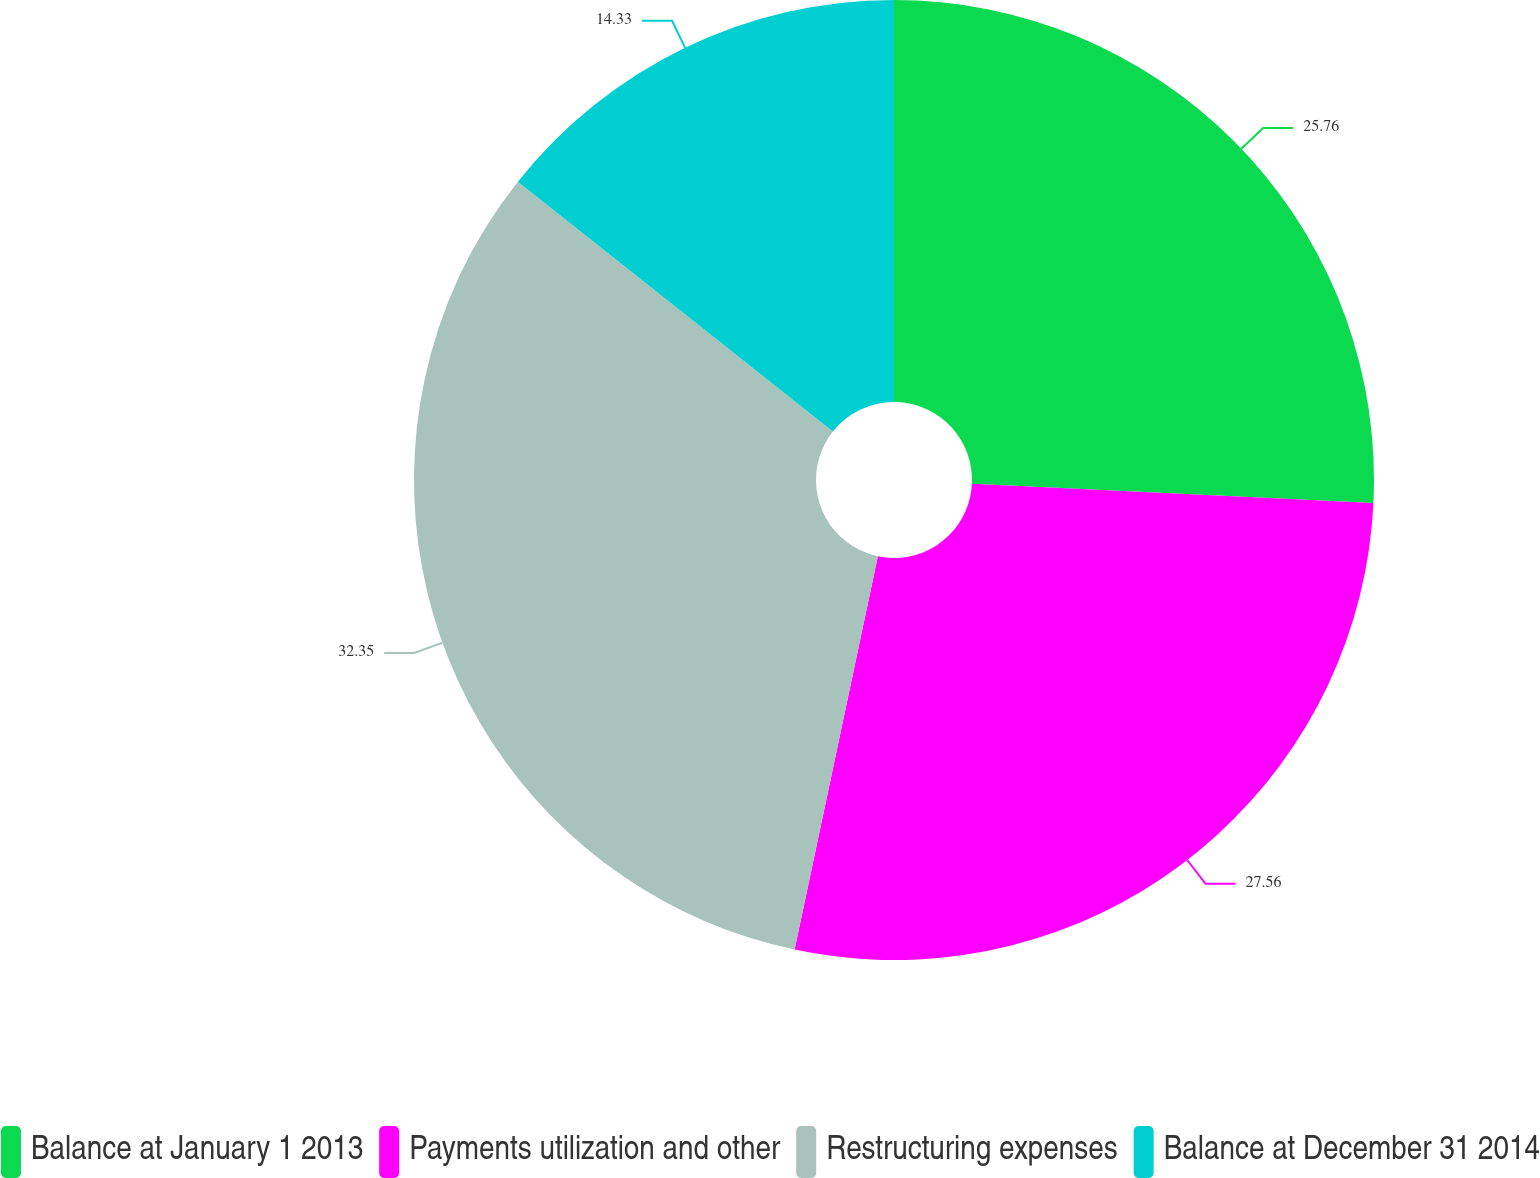Convert chart. <chart><loc_0><loc_0><loc_500><loc_500><pie_chart><fcel>Balance at January 1 2013<fcel>Payments utilization and other<fcel>Restructuring expenses<fcel>Balance at December 31 2014<nl><fcel>25.76%<fcel>27.56%<fcel>32.35%<fcel>14.33%<nl></chart> 